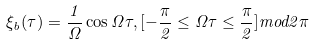Convert formula to latex. <formula><loc_0><loc_0><loc_500><loc_500>\xi _ { b } ( \tau ) = \frac { 1 } { \Omega } \cos \Omega \tau , [ - \frac { \pi } 2 \leq \Omega \tau \leq \frac { \pi } { 2 } ] m o d 2 \pi</formula> 